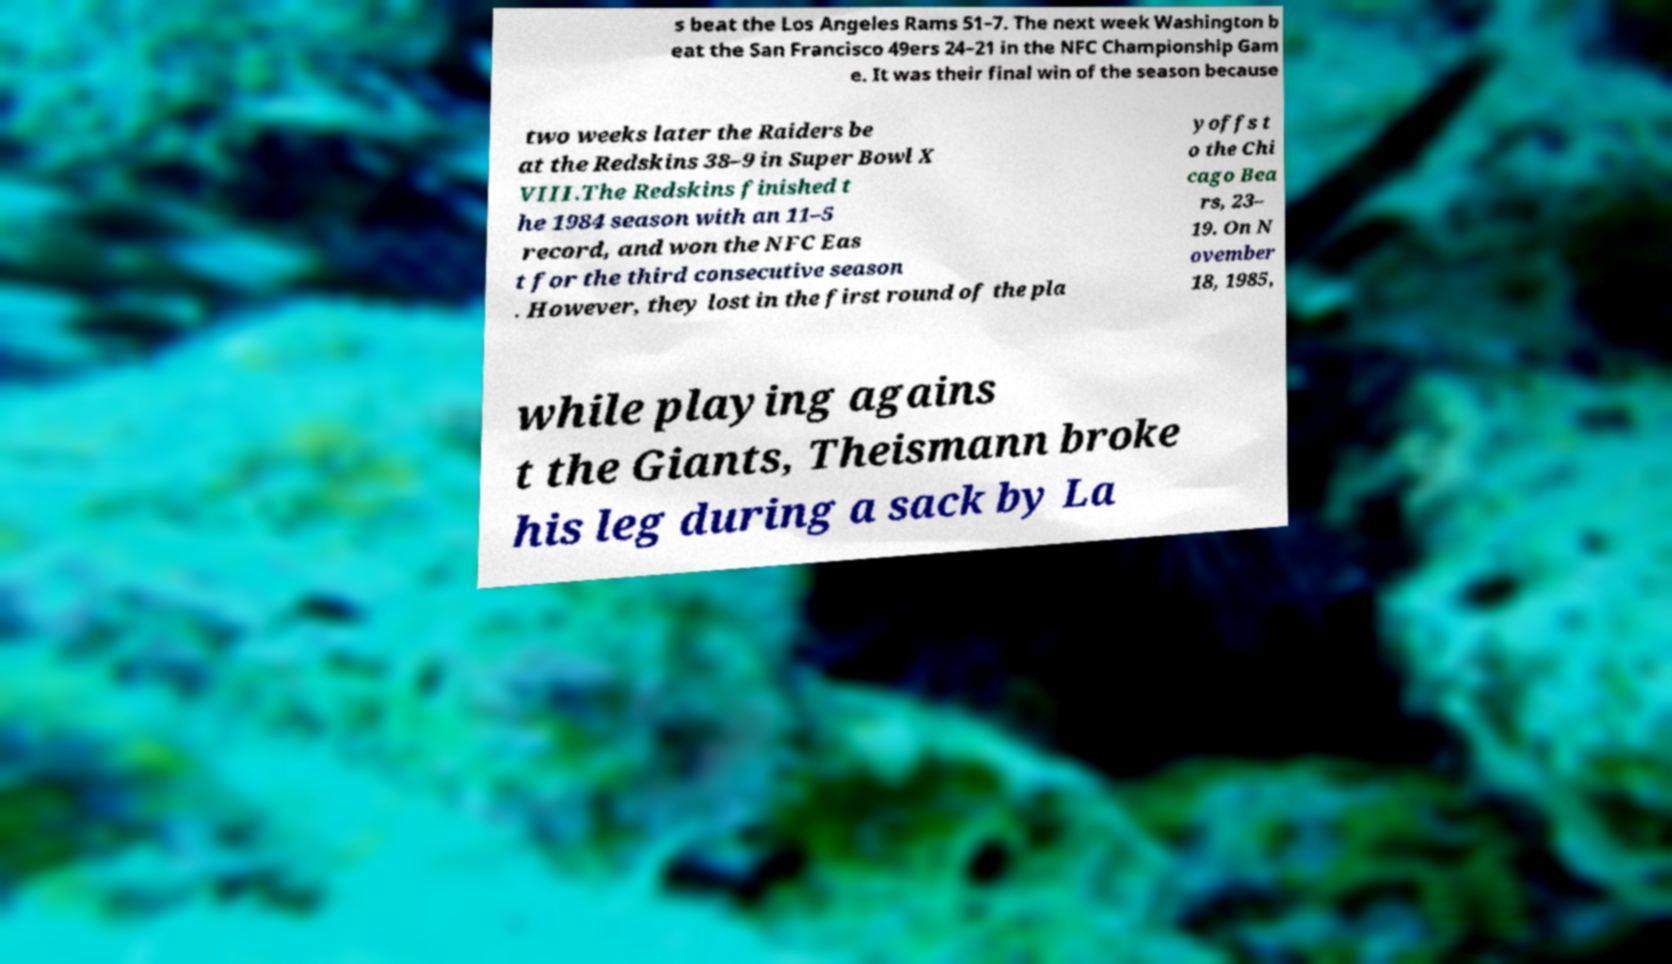Please identify and transcribe the text found in this image. s beat the Los Angeles Rams 51–7. The next week Washington b eat the San Francisco 49ers 24–21 in the NFC Championship Gam e. It was their final win of the season because two weeks later the Raiders be at the Redskins 38–9 in Super Bowl X VIII.The Redskins finished t he 1984 season with an 11–5 record, and won the NFC Eas t for the third consecutive season . However, they lost in the first round of the pla yoffs t o the Chi cago Bea rs, 23– 19. On N ovember 18, 1985, while playing agains t the Giants, Theismann broke his leg during a sack by La 